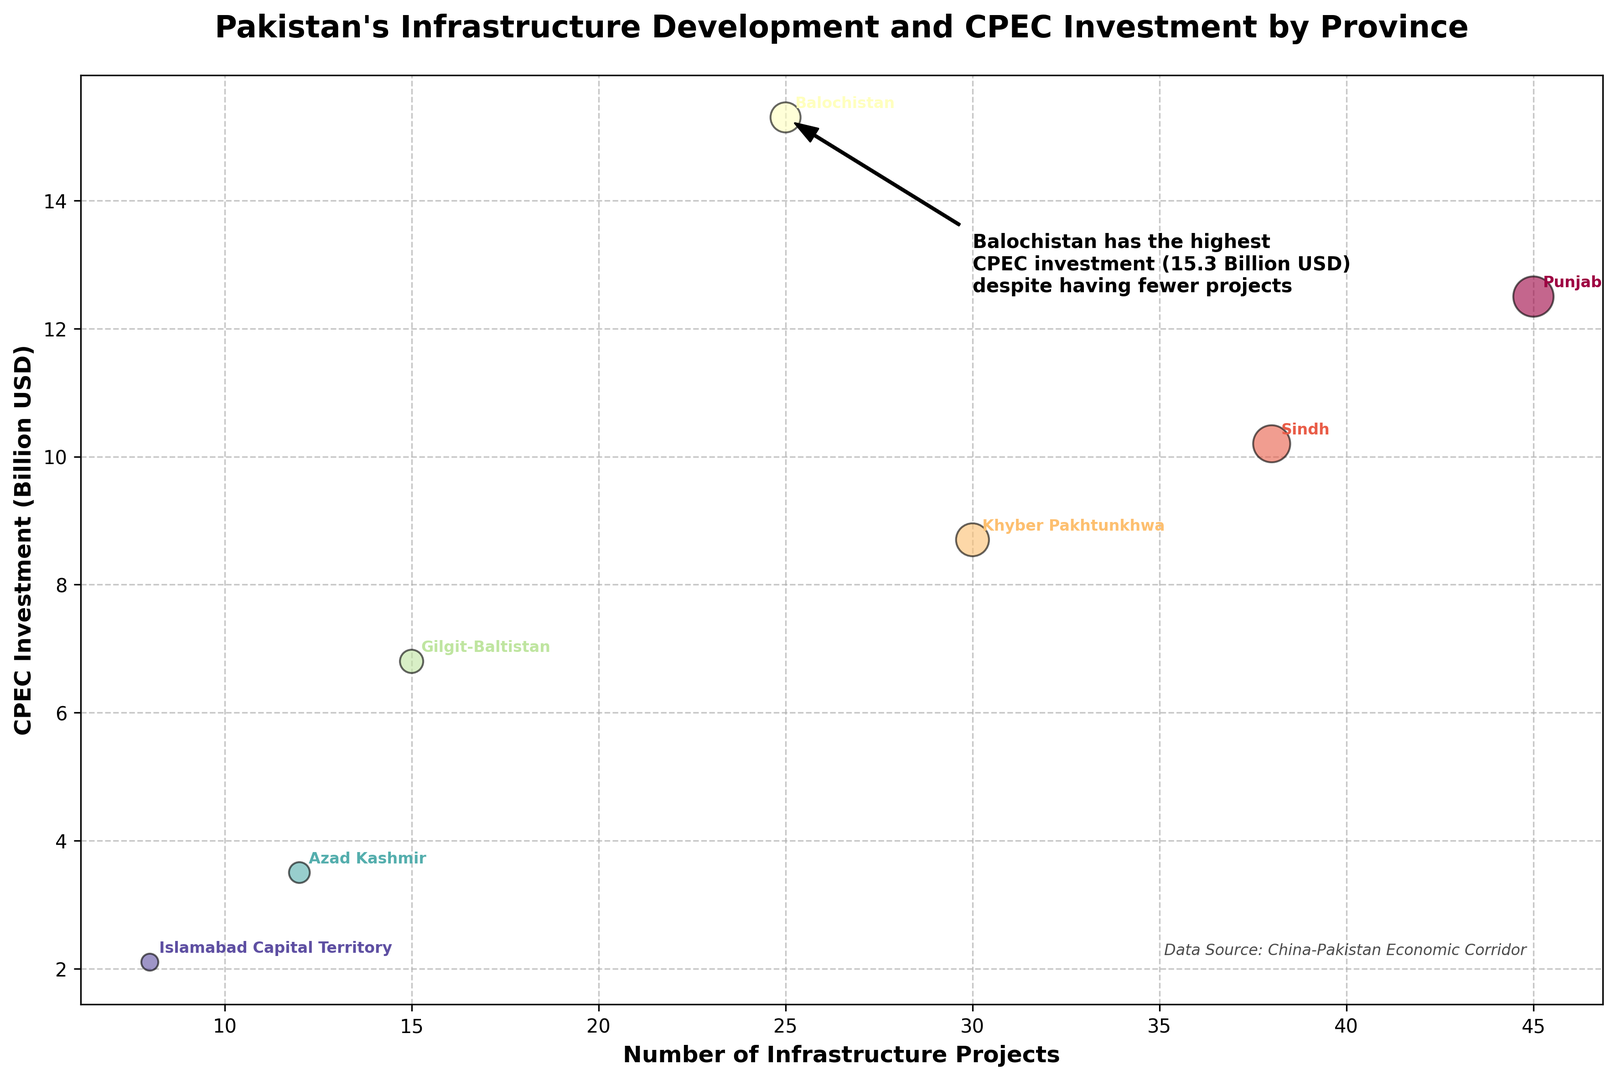Which province has the highest CPEC investment? According to the figure, the highest CPEC investment belongs to the province with the topmost marker on the vertical axis.
Answer: Balochistan Which province has the most infrastructure projects? The figure indicates this by the province with the furthest marker to the right on the horizontal axis.
Answer: Punjab How many infrastructure projects does Balochistan have? By looking at the horizontal position of Balochistan's marker, we can determine the number of infrastructure projects.
Answer: 25 What is the sum of CPEC investments in Punjab and Sindh? Add the CPEC investments for Punjab and Sindh; i.e., 12.5 + 10.2.
Answer: 22.7 Billion USD Which province has more infrastructure projects, Sindh or Khyber Pakhtunkhwa? Compare the horizontal position of markers for Sindh and Khyber Pakhtunkhwa.
Answer: Sindh What is the difference in CPEC investment between Balochistan and Punjab? Subtract Punjab's investment from Balochistan's; i.e., 15.3 - 12.5.
Answer: 2.8 Billion USD Which province has fewer infrastructure projects, Gilgit-Baltistan or Azad Kashmir? Compare the horizontal position of markers for Gilgit-Baltistan and Azad Kashmir.
Answer: Azad Kashmir What's the average CPEC investment across all provinces? Sum all the CPEC investments and divide by the number of provinces; i.e., (12.5 + 10.2 + 8.7 + 15.3 + 6.8 + 3.5 + 2.1) / 7.
Answer: 8.7 Billion USD Which province has the lowest CPEC investment? The lowest CPEC investment belongs to the province with the bottom-most marker on the vertical axis.
Answer: Islamabad Capital Territory What is the combined number of infrastructure projects for Gilgit-Baltistan and Azad Kashmir? Add the number of projects for both provinces; i.e., 15 + 12.
Answer: 27 